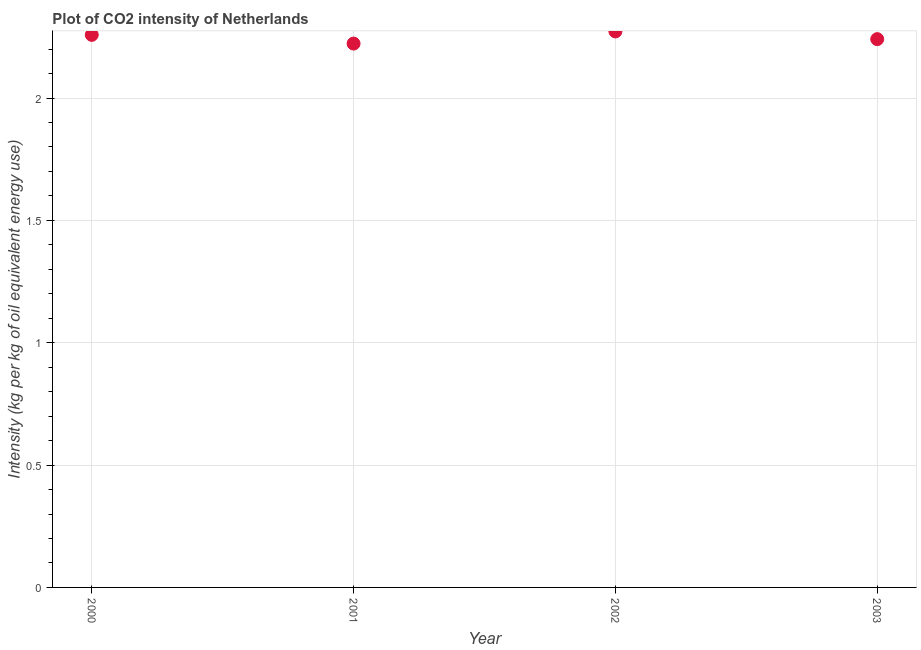What is the co2 intensity in 2000?
Keep it short and to the point. 2.26. Across all years, what is the maximum co2 intensity?
Offer a very short reply. 2.27. Across all years, what is the minimum co2 intensity?
Offer a very short reply. 2.22. What is the sum of the co2 intensity?
Offer a terse response. 8.99. What is the difference between the co2 intensity in 2002 and 2003?
Your answer should be compact. 0.03. What is the average co2 intensity per year?
Your answer should be compact. 2.25. What is the median co2 intensity?
Your response must be concise. 2.25. In how many years, is the co2 intensity greater than 2 kg?
Make the answer very short. 4. What is the ratio of the co2 intensity in 2000 to that in 2001?
Ensure brevity in your answer.  1.02. Is the co2 intensity in 2000 less than that in 2001?
Provide a succinct answer. No. What is the difference between the highest and the second highest co2 intensity?
Offer a very short reply. 0.01. Is the sum of the co2 intensity in 2002 and 2003 greater than the maximum co2 intensity across all years?
Your answer should be compact. Yes. What is the difference between the highest and the lowest co2 intensity?
Offer a very short reply. 0.05. Does the co2 intensity monotonically increase over the years?
Make the answer very short. No. How many dotlines are there?
Give a very brief answer. 1. How many years are there in the graph?
Make the answer very short. 4. What is the difference between two consecutive major ticks on the Y-axis?
Your response must be concise. 0.5. Are the values on the major ticks of Y-axis written in scientific E-notation?
Keep it short and to the point. No. What is the title of the graph?
Keep it short and to the point. Plot of CO2 intensity of Netherlands. What is the label or title of the Y-axis?
Ensure brevity in your answer.  Intensity (kg per kg of oil equivalent energy use). What is the Intensity (kg per kg of oil equivalent energy use) in 2000?
Keep it short and to the point. 2.26. What is the Intensity (kg per kg of oil equivalent energy use) in 2001?
Give a very brief answer. 2.22. What is the Intensity (kg per kg of oil equivalent energy use) in 2002?
Keep it short and to the point. 2.27. What is the Intensity (kg per kg of oil equivalent energy use) in 2003?
Keep it short and to the point. 2.24. What is the difference between the Intensity (kg per kg of oil equivalent energy use) in 2000 and 2001?
Offer a very short reply. 0.04. What is the difference between the Intensity (kg per kg of oil equivalent energy use) in 2000 and 2002?
Your answer should be compact. -0.01. What is the difference between the Intensity (kg per kg of oil equivalent energy use) in 2000 and 2003?
Provide a short and direct response. 0.02. What is the difference between the Intensity (kg per kg of oil equivalent energy use) in 2001 and 2002?
Provide a succinct answer. -0.05. What is the difference between the Intensity (kg per kg of oil equivalent energy use) in 2001 and 2003?
Provide a short and direct response. -0.02. What is the difference between the Intensity (kg per kg of oil equivalent energy use) in 2002 and 2003?
Your response must be concise. 0.03. What is the ratio of the Intensity (kg per kg of oil equivalent energy use) in 2000 to that in 2001?
Your response must be concise. 1.02. What is the ratio of the Intensity (kg per kg of oil equivalent energy use) in 2000 to that in 2002?
Keep it short and to the point. 0.99. What is the ratio of the Intensity (kg per kg of oil equivalent energy use) in 2000 to that in 2003?
Offer a terse response. 1.01. What is the ratio of the Intensity (kg per kg of oil equivalent energy use) in 2001 to that in 2002?
Offer a very short reply. 0.98. What is the ratio of the Intensity (kg per kg of oil equivalent energy use) in 2002 to that in 2003?
Keep it short and to the point. 1.01. 